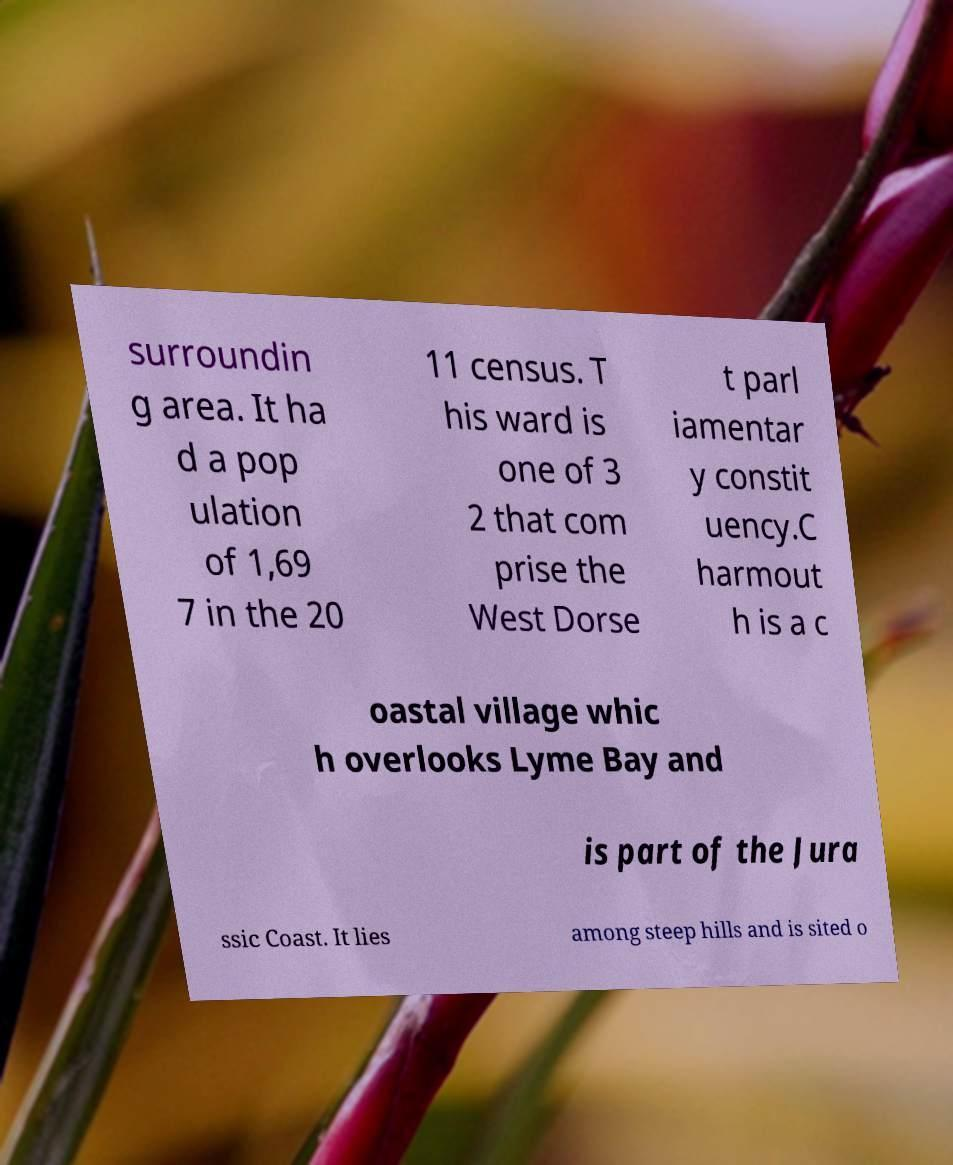There's text embedded in this image that I need extracted. Can you transcribe it verbatim? surroundin g area. It ha d a pop ulation of 1,69 7 in the 20 11 census. T his ward is one of 3 2 that com prise the West Dorse t parl iamentar y constit uency.C harmout h is a c oastal village whic h overlooks Lyme Bay and is part of the Jura ssic Coast. It lies among steep hills and is sited o 